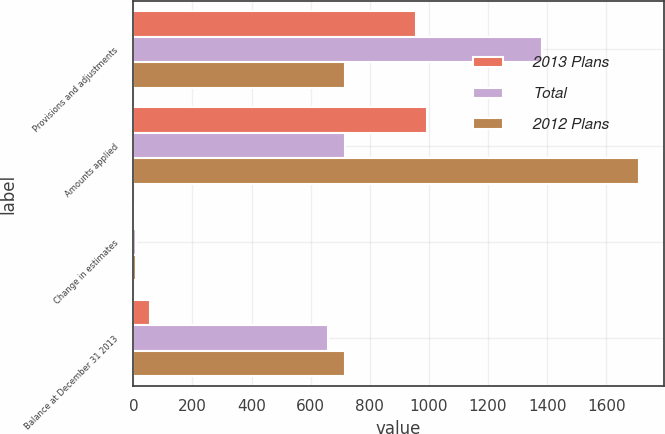Convert chart to OTSL. <chart><loc_0><loc_0><loc_500><loc_500><stacked_bar_chart><ecel><fcel>Provisions and adjustments<fcel>Amounts applied<fcel>Change in estimates<fcel>Balance at December 31 2013<nl><fcel>2013 Plans<fcel>957<fcel>994<fcel>1<fcel>58<nl><fcel>Total<fcel>1383<fcel>716<fcel>9<fcel>658<nl><fcel>2012 Plans<fcel>716<fcel>1710<fcel>8<fcel>716<nl></chart> 